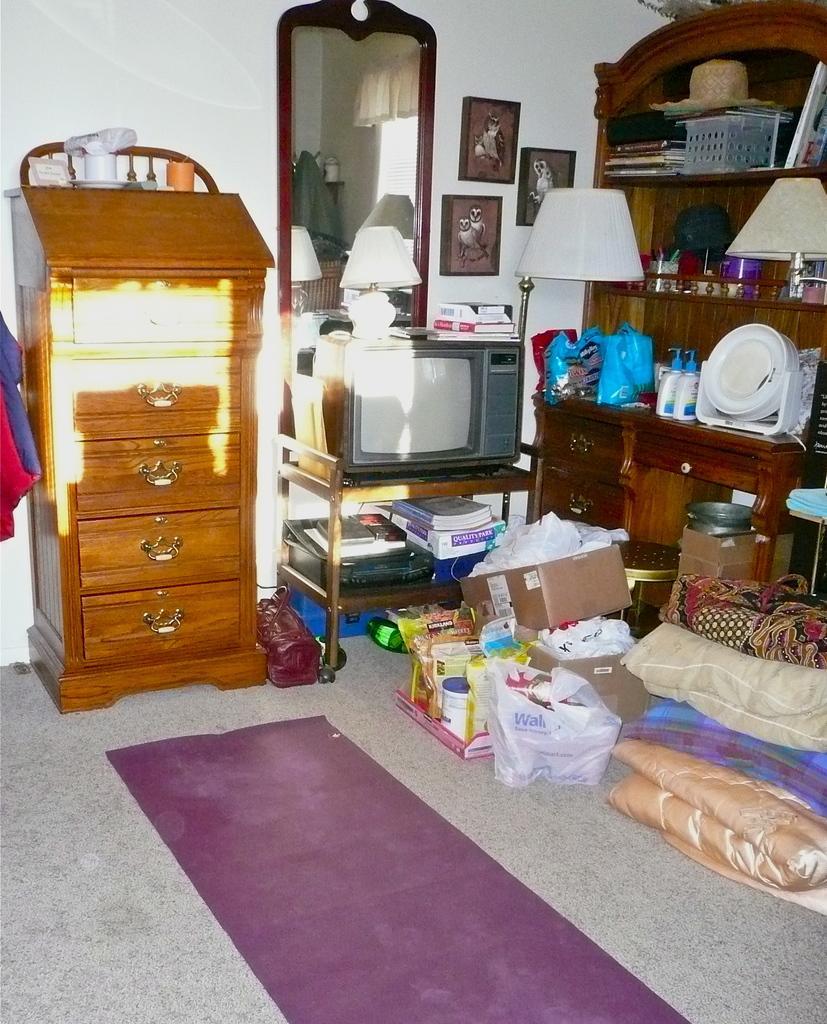Please provide a concise description of this image. In this image in the center there is a chest of drawers. On the right side there is a TV on the stand and there are books on the stand, on the top of the TV there is lamp and there are books. In front of the TV on the floor there are objects. On the right side there is a cupboard and on the cupboard there are plates, bottles, there is a hat and there are frames on the wall. On the left side there is an object which is in red and blue colour. On the floor there is a mat and there is a purse. 